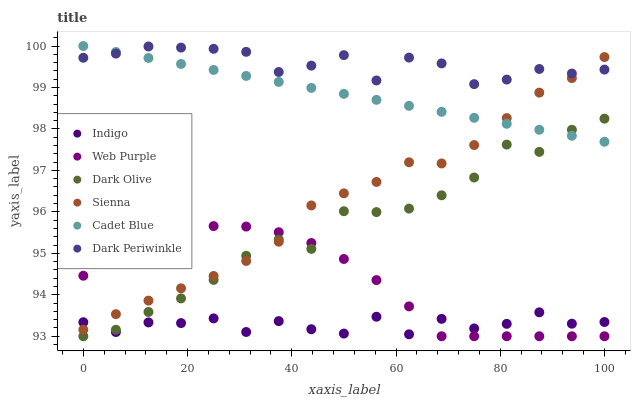Does Indigo have the minimum area under the curve?
Answer yes or no. Yes. Does Dark Periwinkle have the maximum area under the curve?
Answer yes or no. Yes. Does Dark Olive have the minimum area under the curve?
Answer yes or no. No. Does Dark Olive have the maximum area under the curve?
Answer yes or no. No. Is Cadet Blue the smoothest?
Answer yes or no. Yes. Is Indigo the roughest?
Answer yes or no. Yes. Is Dark Olive the smoothest?
Answer yes or no. No. Is Dark Olive the roughest?
Answer yes or no. No. Does Dark Olive have the lowest value?
Answer yes or no. Yes. Does Indigo have the lowest value?
Answer yes or no. No. Does Cadet Blue have the highest value?
Answer yes or no. Yes. Does Dark Olive have the highest value?
Answer yes or no. No. Is Dark Olive less than Dark Periwinkle?
Answer yes or no. Yes. Is Dark Periwinkle greater than Web Purple?
Answer yes or no. Yes. Does Sienna intersect Indigo?
Answer yes or no. Yes. Is Sienna less than Indigo?
Answer yes or no. No. Is Sienna greater than Indigo?
Answer yes or no. No. Does Dark Olive intersect Dark Periwinkle?
Answer yes or no. No. 